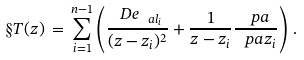<formula> <loc_0><loc_0><loc_500><loc_500>\S T ( z ) \, = \, \sum _ { i = 1 } ^ { n - 1 } \left ( \frac { \ D e _ { \ a l _ { i } } } { ( z - z _ { i } ) ^ { 2 } } + \frac { 1 } { z - z _ { i } } \frac { \ p a } { \ p a z _ { i } } \right ) \, .</formula> 